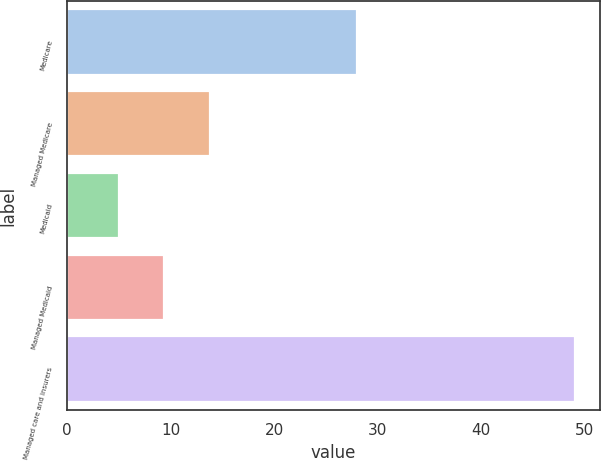Convert chart to OTSL. <chart><loc_0><loc_0><loc_500><loc_500><bar_chart><fcel>Medicare<fcel>Managed Medicare<fcel>Medicaid<fcel>Managed Medicaid<fcel>Managed care and insurers<nl><fcel>28<fcel>13.8<fcel>5<fcel>9.4<fcel>49<nl></chart> 